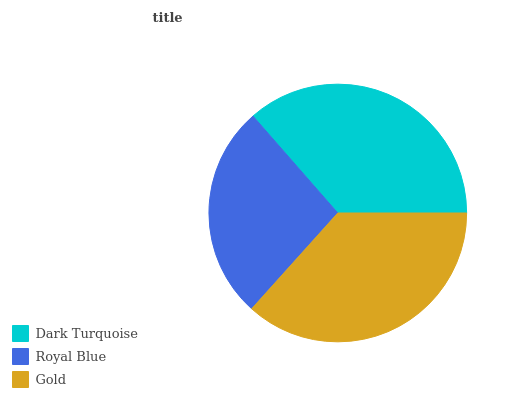Is Royal Blue the minimum?
Answer yes or no. Yes. Is Gold the maximum?
Answer yes or no. Yes. Is Gold the minimum?
Answer yes or no. No. Is Royal Blue the maximum?
Answer yes or no. No. Is Gold greater than Royal Blue?
Answer yes or no. Yes. Is Royal Blue less than Gold?
Answer yes or no. Yes. Is Royal Blue greater than Gold?
Answer yes or no. No. Is Gold less than Royal Blue?
Answer yes or no. No. Is Dark Turquoise the high median?
Answer yes or no. Yes. Is Dark Turquoise the low median?
Answer yes or no. Yes. Is Gold the high median?
Answer yes or no. No. Is Royal Blue the low median?
Answer yes or no. No. 